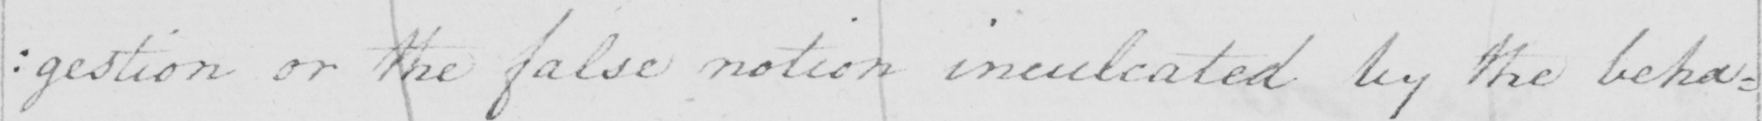Can you read and transcribe this handwriting? : gestion or the false notion inculcated by the behav= 